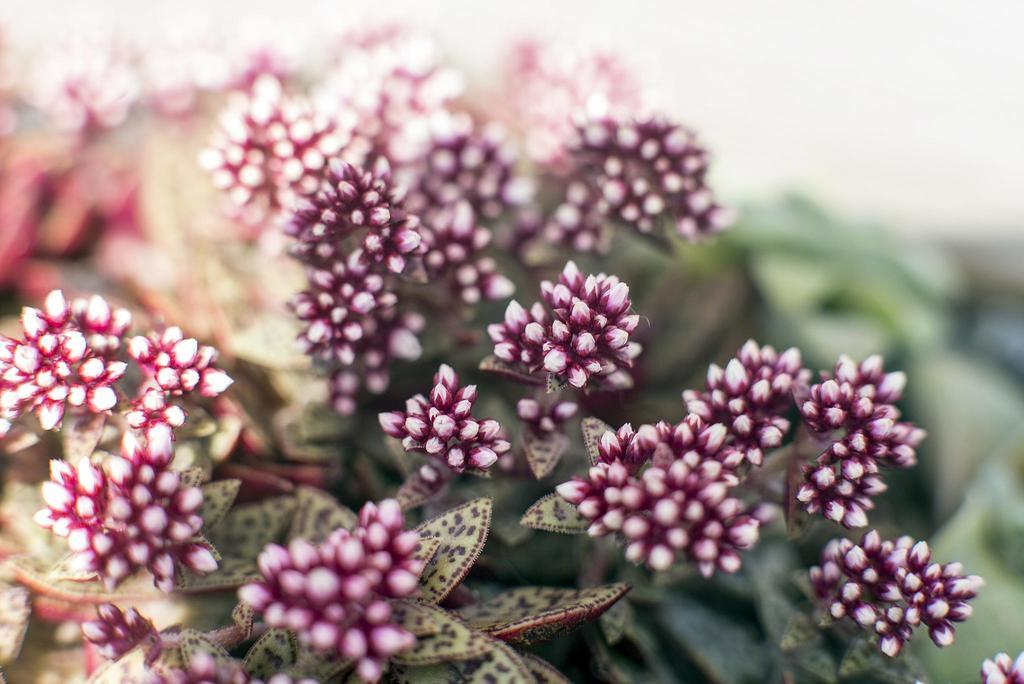What type of plants can be seen in the image? There are plants with flowers in the image. Can you describe the background of the image? The background of the image is blurry. How much eggnog is being poured into the plants in the image? There is no eggnog present in the image, and the plants are not being poured into. 